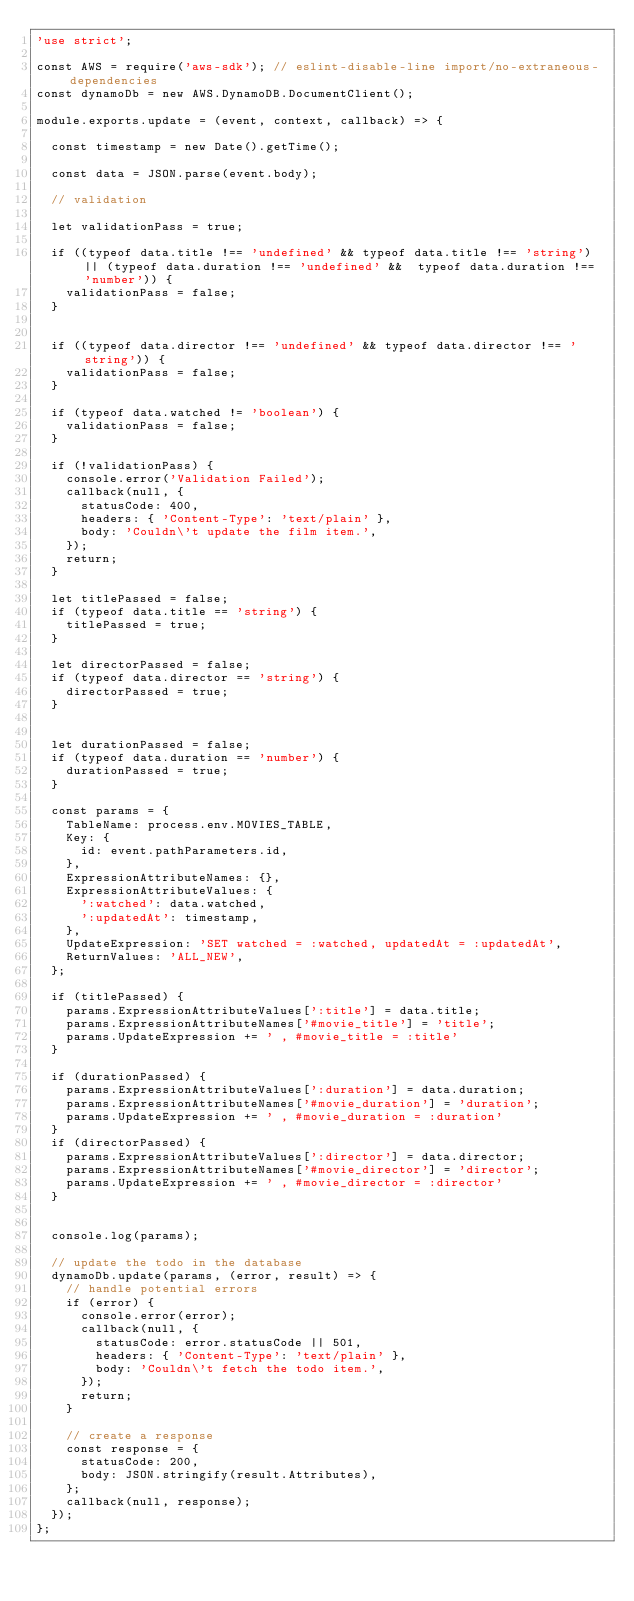<code> <loc_0><loc_0><loc_500><loc_500><_JavaScript_>'use strict';

const AWS = require('aws-sdk'); // eslint-disable-line import/no-extraneous-dependencies
const dynamoDb = new AWS.DynamoDB.DocumentClient();

module.exports.update = (event, context, callback) => {

  const timestamp = new Date().getTime();

  const data = JSON.parse(event.body);

  // validation

  let validationPass = true;

  if ((typeof data.title !== 'undefined' && typeof data.title !== 'string') || (typeof data.duration !== 'undefined' &&  typeof data.duration !== 'number')) {
    validationPass = false;
  }


  if ((typeof data.director !== 'undefined' && typeof data.director !== 'string')) {
    validationPass = false;
  }

  if (typeof data.watched != 'boolean') {
    validationPass = false;
  }

  if (!validationPass) {
    console.error('Validation Failed');
    callback(null, {
      statusCode: 400,
      headers: { 'Content-Type': 'text/plain' },
      body: 'Couldn\'t update the film item.',
    });
    return;
  }

  let titlePassed = false;
  if (typeof data.title == 'string') {
    titlePassed = true;
  }

  let directorPassed = false;
  if (typeof data.director == 'string') {
    directorPassed = true;
  }


  let durationPassed = false;
  if (typeof data.duration == 'number') {
    durationPassed = true;
  }

  const params = {
    TableName: process.env.MOVIES_TABLE,
    Key: {
      id: event.pathParameters.id,
    },
    ExpressionAttributeNames: {},
    ExpressionAttributeValues: {
      ':watched': data.watched,
      ':updatedAt': timestamp,
    },
    UpdateExpression: 'SET watched = :watched, updatedAt = :updatedAt',
    ReturnValues: 'ALL_NEW',
  };

  if (titlePassed) {
    params.ExpressionAttributeValues[':title'] = data.title;
    params.ExpressionAttributeNames['#movie_title'] = 'title';    
    params.UpdateExpression += ' , #movie_title = :title'
  }

  if (durationPassed) {
    params.ExpressionAttributeValues[':duration'] = data.duration;
    params.ExpressionAttributeNames['#movie_duration'] = 'duration';    
    params.UpdateExpression += ' , #movie_duration = :duration'
  }
  if (directorPassed) {
    params.ExpressionAttributeValues[':director'] = data.director;
    params.ExpressionAttributeNames['#movie_director'] = 'director';    
    params.UpdateExpression += ' , #movie_director = :director'
  }


  console.log(params);

  // update the todo in the database
  dynamoDb.update(params, (error, result) => {
    // handle potential errors
    if (error) {
      console.error(error);
      callback(null, {
        statusCode: error.statusCode || 501,
        headers: { 'Content-Type': 'text/plain' },
        body: 'Couldn\'t fetch the todo item.',
      });
      return;
    }

    // create a response
    const response = {
      statusCode: 200,
      body: JSON.stringify(result.Attributes),
    };
    callback(null, response);
  });
};
</code> 